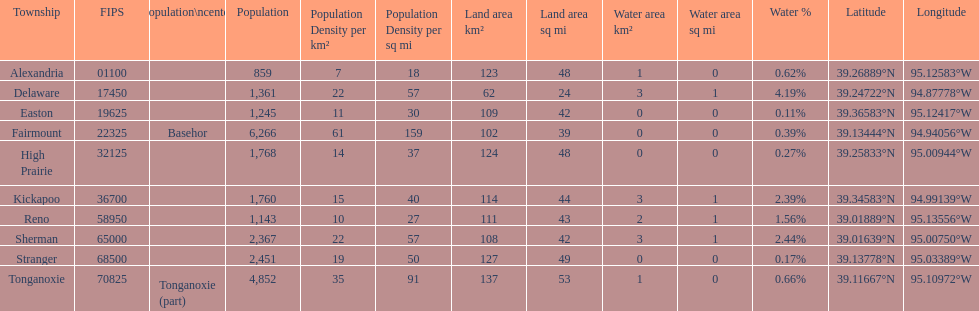What township has the largest population? Fairmount. 